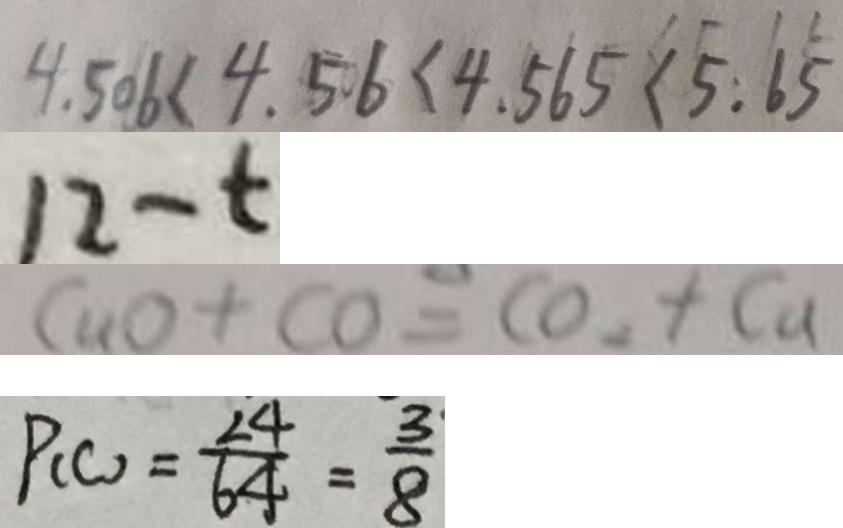Convert formula to latex. <formula><loc_0><loc_0><loc_500><loc_500>4 . 5 0 6 < 4 . 5 6 < 4 . 5 6 5 < 5 . 6 \dot { 5 } 
 1 2 - t 
 C u O + C O = C O _ { 2 } + C u 
 P _ { ( C ) } = \frac { 2 4 } { 6 4 } = \frac { 3 } { 8 }</formula> 